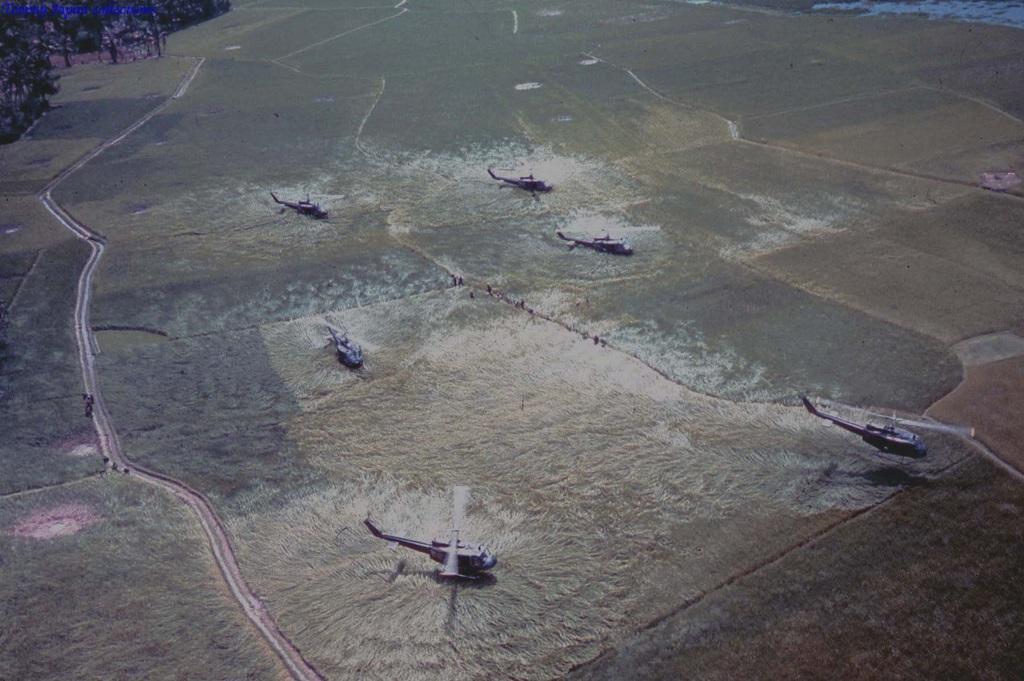Can you describe this image briefly? In this image, we can see helicopters. There are trees in the top left of the image. 